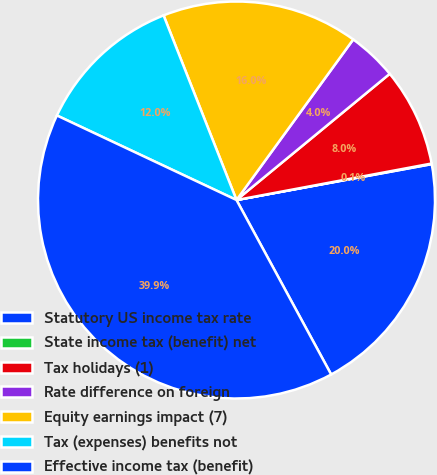Convert chart to OTSL. <chart><loc_0><loc_0><loc_500><loc_500><pie_chart><fcel>Statutory US income tax rate<fcel>State income tax (benefit) net<fcel>Tax holidays (1)<fcel>Rate difference on foreign<fcel>Equity earnings impact (7)<fcel>Tax (expenses) benefits not<fcel>Effective income tax (benefit)<nl><fcel>19.98%<fcel>0.05%<fcel>8.02%<fcel>4.03%<fcel>15.99%<fcel>12.01%<fcel>39.91%<nl></chart> 